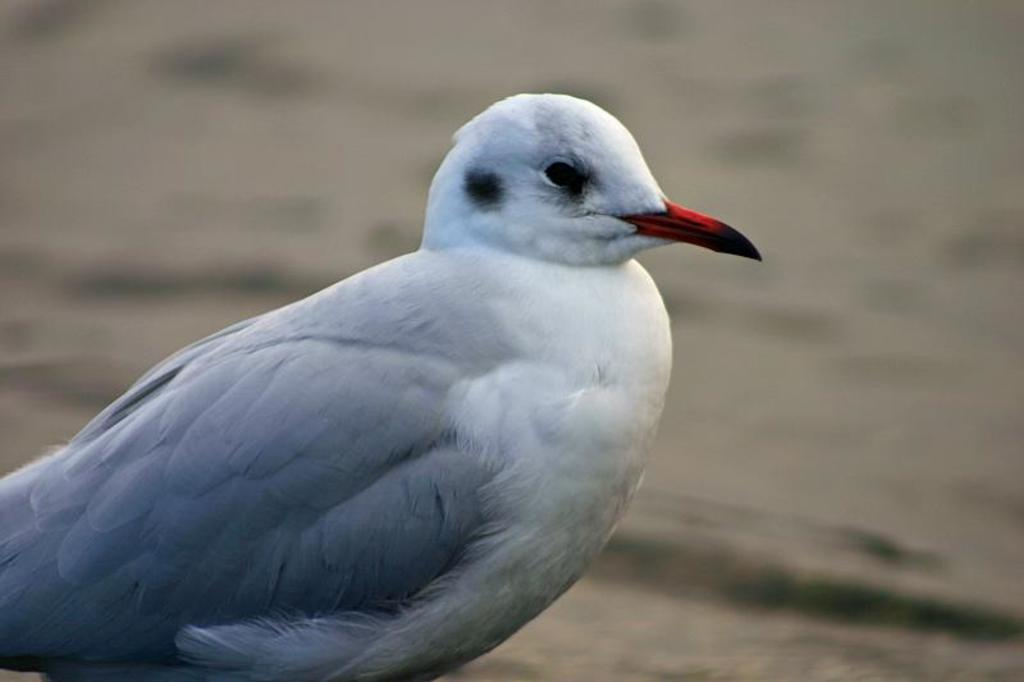What type of animal can be seen in the image? There is a bird in the image. Can you describe the background of the image? The background of the image is blurred. What process is the bird's uncle performing at the train station in the image? There is no train station, process, or uncle present in the image; it only features a bird with a blurred background. 